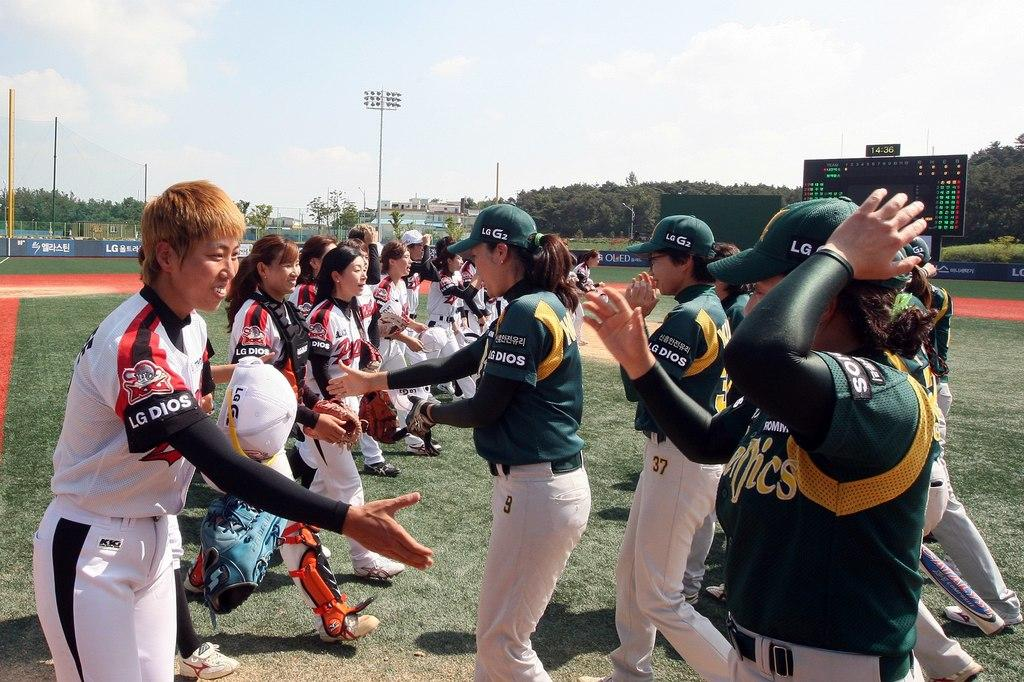<image>
Relay a brief, clear account of the picture shown. an LG dios word on the side of a person's arm 